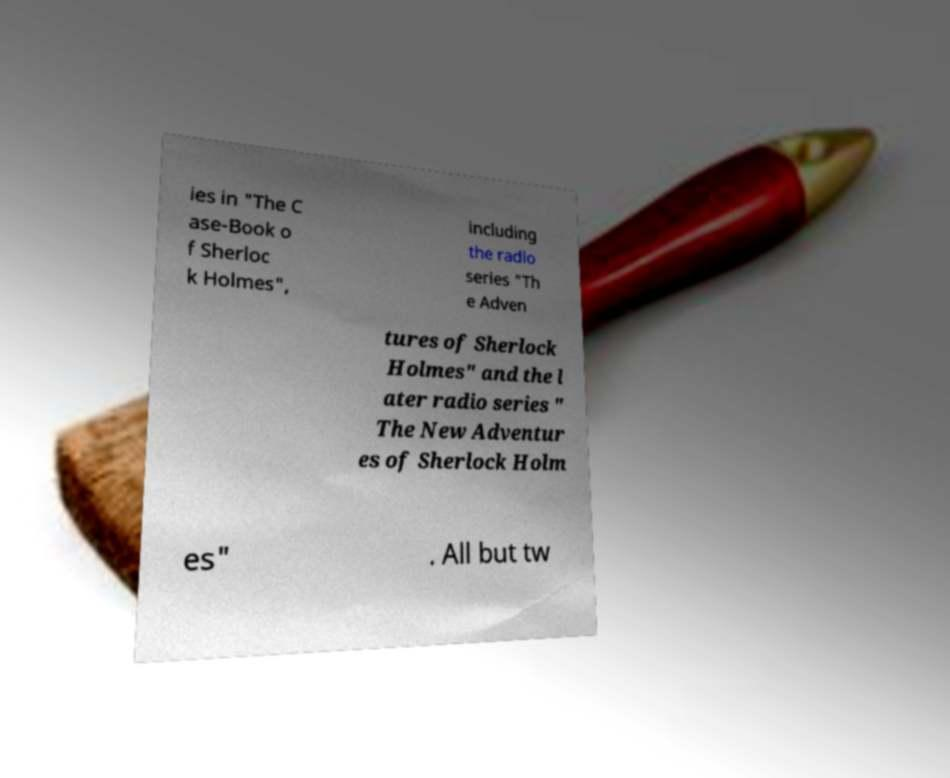Please identify and transcribe the text found in this image. ies in "The C ase-Book o f Sherloc k Holmes", including the radio series "Th e Adven tures of Sherlock Holmes" and the l ater radio series " The New Adventur es of Sherlock Holm es" . All but tw 